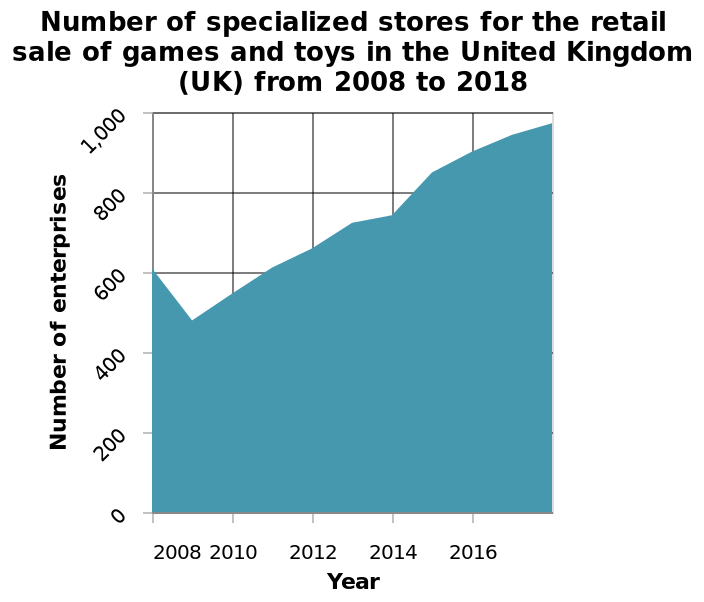<image>
What happened to sales between 2008 and 2010? Sales experienced a decline between 2008 and 2010. How did the market perform between 2010 and 2018?  The market showed a steady recovery between 2010 and 2018. Over what time period did the decline in sales occur? The decline in sales occurred from 2008 to 2010. Offer a thorough analysis of the image. WIthin the above chart we can see a decline of sales from 2008 to 2010 followed by a steady recovery of the market from 2010 to 2018. 